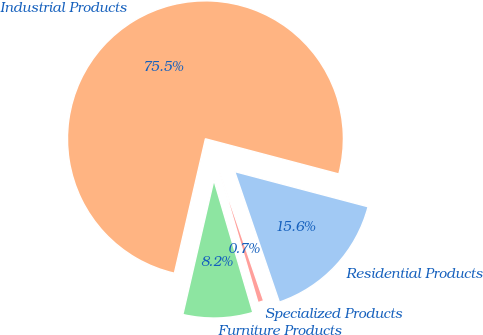Convert chart to OTSL. <chart><loc_0><loc_0><loc_500><loc_500><pie_chart><fcel>Residential Products<fcel>Industrial Products<fcel>Furniture Products<fcel>Specialized Products<nl><fcel>15.65%<fcel>75.49%<fcel>8.17%<fcel>0.69%<nl></chart> 